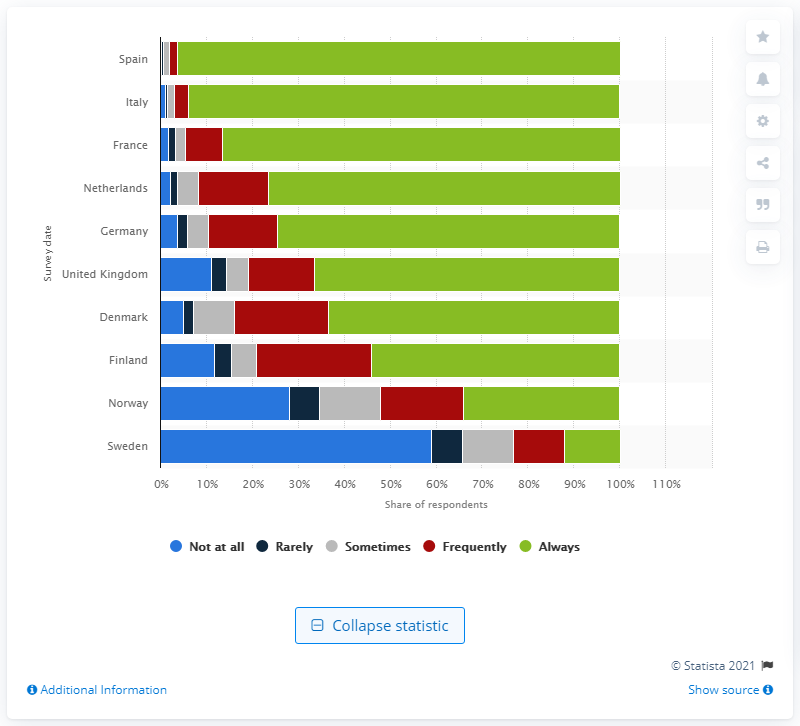Mention a couple of crucial points in this snapshot. Ninety-six point four percent of Spanish respondents always wore a face mask outside in the preceding week. 